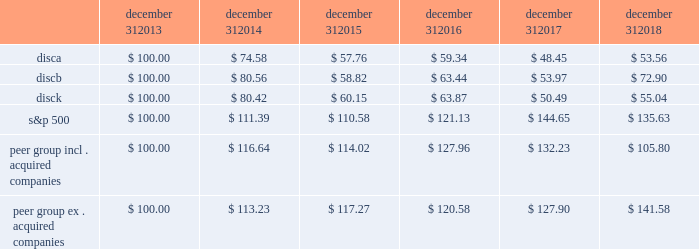Stock performance graph the following graph sets forth the cumulative total shareholder return on our series a common stock , series b common stock and series c common stock as compared with the cumulative total return of the companies listed in the standard and poor 2019s 500 stock index ( 201cs&p 500 index 201d ) and a peer group of companies comprised of cbs corporation class b common stock , scripps network interactive , inc .
( acquired by the company in march 2018 ) , time warner , inc .
( acquired by at&t inc .
In june 2018 ) , twenty-first century fox , inc .
Class a common stock ( news corporation class a common stock prior to june 2013 ) , viacom , inc .
Class b common stock and the walt disney company .
The graph assumes $ 100 originally invested on december 31 , 2013 in each of our series a common stock , series b common stock and series c common stock , the s&p 500 index , and the stock of our peer group companies , including reinvestment of dividends , for the years ended december 31 , 2014 , 2015 , 2016 , 2017 and 2018 .
Two peer companies , scripps networks interactive , inc .
And time warner , inc. , were acquired in 2018 .
The stock performance chart shows the peer group including scripps networks interactive , inc .
And time warner , inc .
And excluding both acquired companies for the entire five year period .
December 31 , december 31 , december 31 , december 31 , december 31 , december 31 .
Equity compensation plan information information regarding securities authorized for issuance under equity compensation plans will be set forth in our definitive proxy statement for our 2019 annual meeting of stockholders under the caption 201csecurities authorized for issuance under equity compensation plans , 201d which is incorporated herein by reference. .
What was the percentage cumulative total shareholder return on disca for the five year period ended december 31 , 2018? 
Computations: ((53.56 - 100) / 100)
Answer: -0.4644. 